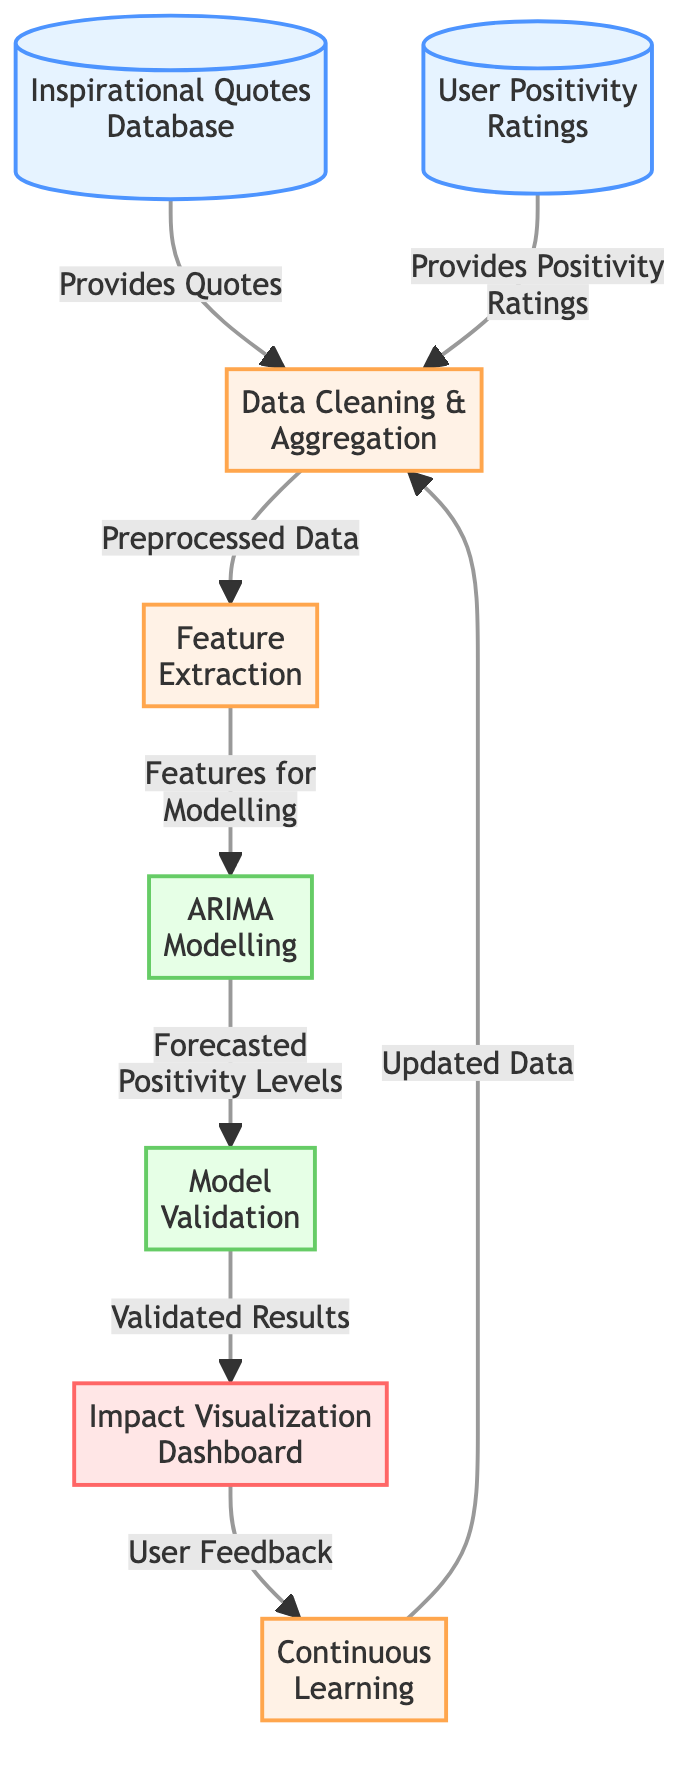What are the two data sources in the diagram? The diagram identifies two data sources: the "Inspirational Quotes Database" and "User Positivity Ratings." These are the starting points of the process, providing the necessary information for analysis.
Answer: Inspirational Quotes Database, User Positivity Ratings What is the first processing step shown in the diagram? According to the diagram, the first processing step is "Data Cleaning & Aggregation." This indicates that the raw data from the sources will be cleaned and combined before further analysis.
Answer: Data Cleaning & Aggregation How many unique nodes are present in the diagram? Counting the distinct nodes in the diagram shows there are eight total nodes, including data sources, processing steps, and output.
Answer: Eight What follows "Feature Extraction" in the flow of the diagram? "ARIMA Modelling" is the step that follows "Feature Extraction." This indicates that after extracting relevant features from the data, the model will utilize these features for further analysis.
Answer: ARIMA Modelling What type of output does the model generate in the diagram? The model generates "Forecasted Positivity Levels" after the ARIMA modelling process. This output aims to predict future positivity based on the data provided.
Answer: Forecasted Positivity Levels What is the purpose of the "Impact Visualization Dashboard"? The "Impact Visualization Dashboard" is designed to present "Validated Results" to users. It serves to visualize the outcomes of the model's predictions for better understanding and engagement.
Answer: Validated Results What leads to "Continuous Learning" in the diagram? "User Feedback" leads to the "Continuous Learning" step. This suggests that after validation and visualization, user input is critical for refining the process continuously.
Answer: User Feedback How does the diagram indicate the flow of updating the data? The flow to update the data is indicated by the link from "Continuous Learning" back to "Data Cleaning & Aggregation," showing the cyclical nature of learning and adaptation based on user feedback.
Answer: Data Cleaning & Aggregation 